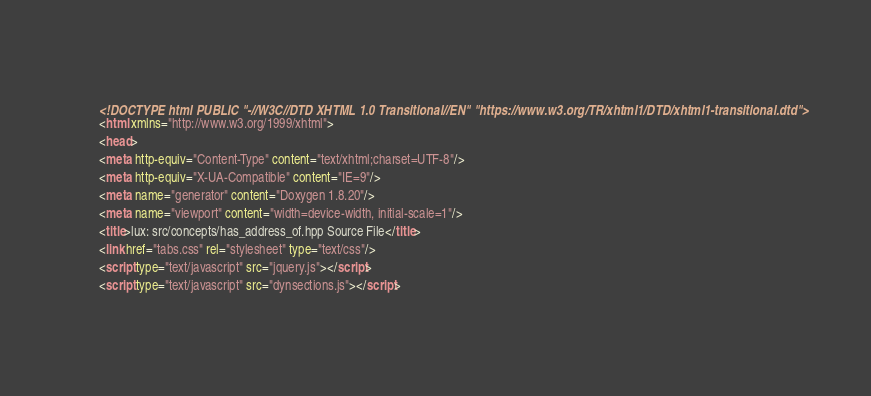Convert code to text. <code><loc_0><loc_0><loc_500><loc_500><_HTML_><!DOCTYPE html PUBLIC "-//W3C//DTD XHTML 1.0 Transitional//EN" "https://www.w3.org/TR/xhtml1/DTD/xhtml1-transitional.dtd">
<html xmlns="http://www.w3.org/1999/xhtml">
<head>
<meta http-equiv="Content-Type" content="text/xhtml;charset=UTF-8"/>
<meta http-equiv="X-UA-Compatible" content="IE=9"/>
<meta name="generator" content="Doxygen 1.8.20"/>
<meta name="viewport" content="width=device-width, initial-scale=1"/>
<title>lux: src/concepts/has_address_of.hpp Source File</title>
<link href="tabs.css" rel="stylesheet" type="text/css"/>
<script type="text/javascript" src="jquery.js"></script>
<script type="text/javascript" src="dynsections.js"></script></code> 